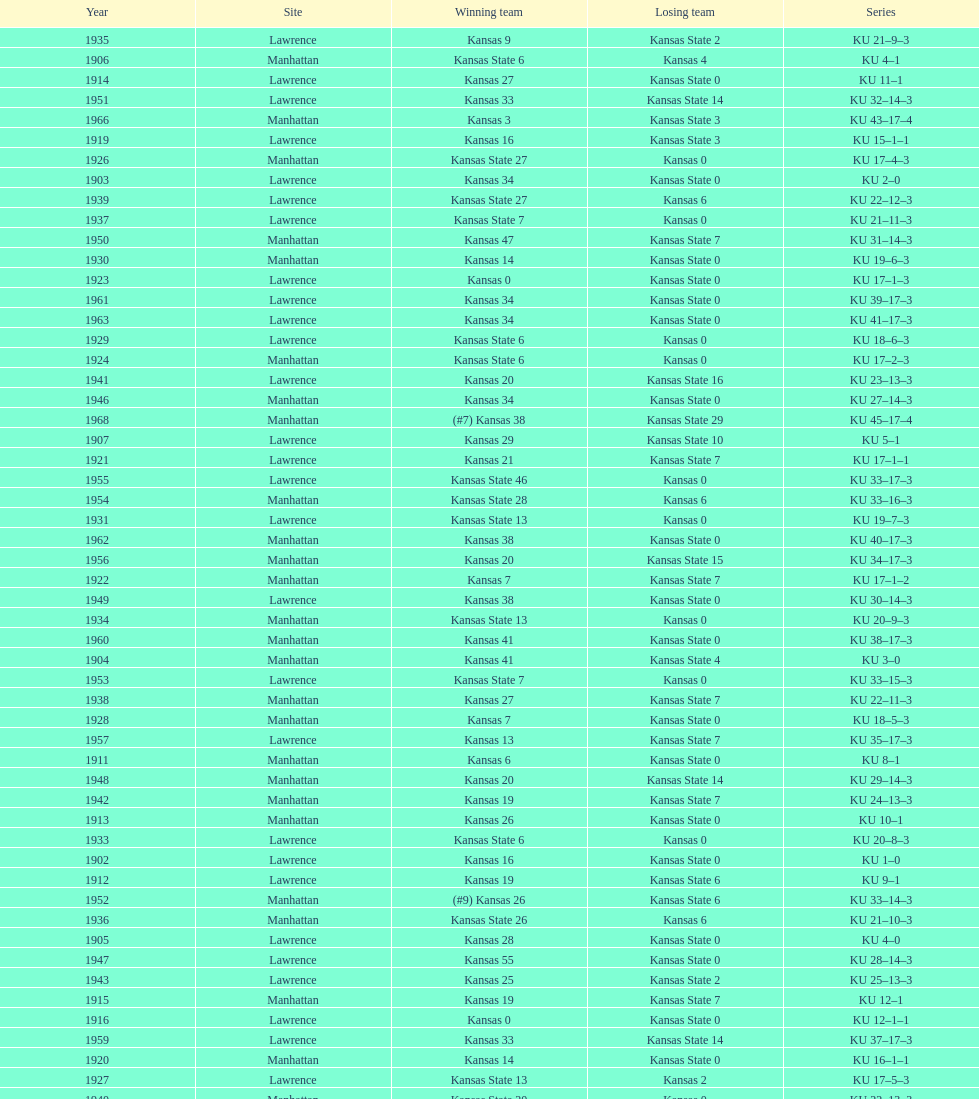How many times did kansas beat kansas state before 1910? 7. 